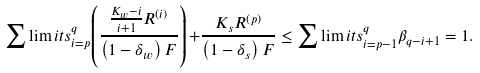<formula> <loc_0><loc_0><loc_500><loc_500>\sum \lim i t s _ { i = p } ^ { q } { \left ( { \frac { { \frac { { { K _ { w } } - i } } { i + 1 } { R ^ { ( i ) } } } } { { \left ( { 1 - { \delta _ { w } } } \right ) F } } } \right ) + } \frac { { { K _ { s } } { R ^ { \left ( p \right ) } } } } { { \left ( { 1 - { \delta _ { s } } } \right ) F } } \leq \sum \lim i t s _ { i = p - 1 } ^ { q } { { { \beta } _ { q - i + 1 } } } = 1 .</formula> 